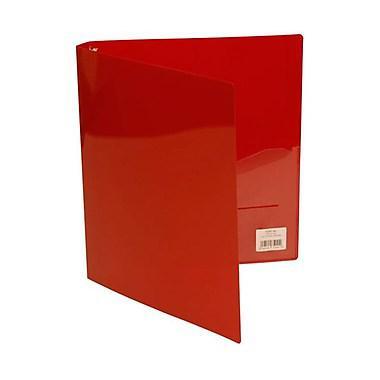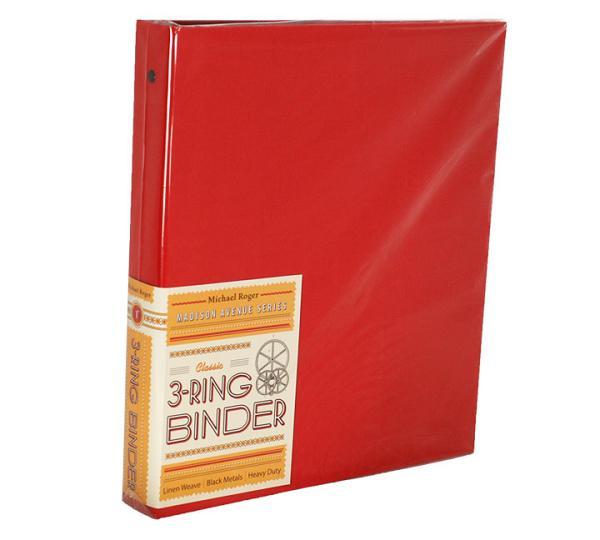The first image is the image on the left, the second image is the image on the right. For the images displayed, is the sentence "The left image contains at least two binders." factually correct? Answer yes or no. No. The first image is the image on the left, the second image is the image on the right. Evaluate the accuracy of this statement regarding the images: "There are fewer than four binders in total.". Is it true? Answer yes or no. Yes. 